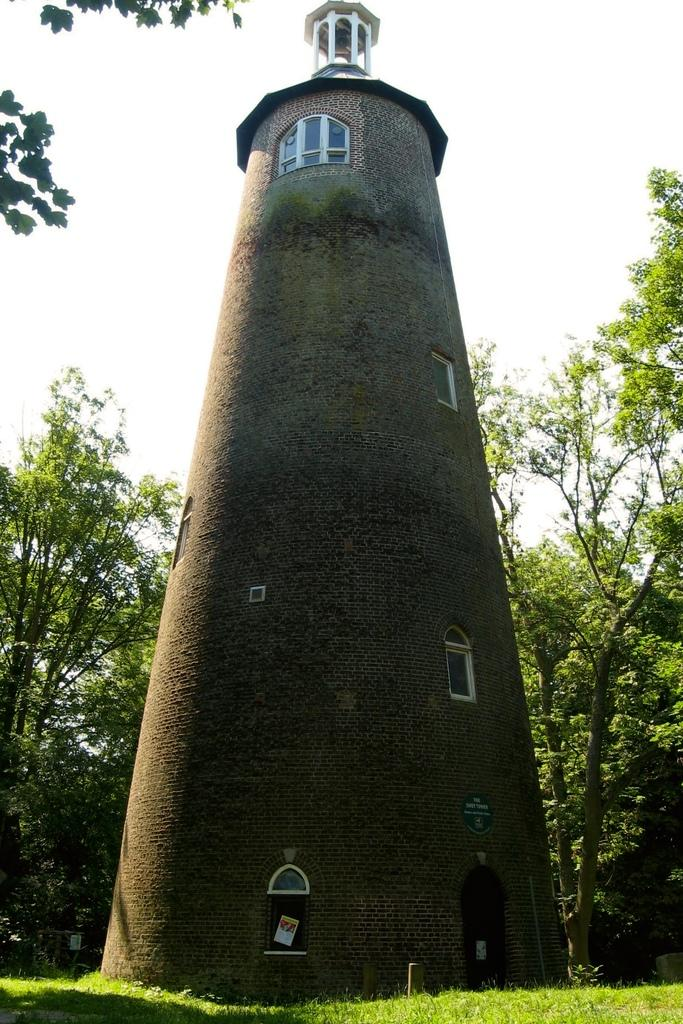What type of structure is in the image? There is a tall building in the image. What is visible in the foreground of the image? There is grass in the foreground of the image. What can be seen in the background of the image? There are trees in the background of the image. What is visible above the building and trees? The sky is visible in the image. How many lizards are crawling on the sheet in the image? There are no lizards or sheets present in the image. 